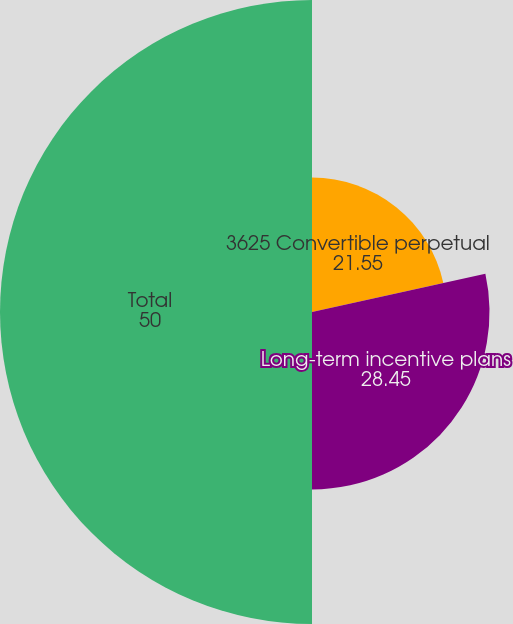Convert chart. <chart><loc_0><loc_0><loc_500><loc_500><pie_chart><fcel>3625 Convertible perpetual<fcel>Long-term incentive plans<fcel>Total<nl><fcel>21.55%<fcel>28.45%<fcel>50.0%<nl></chart> 